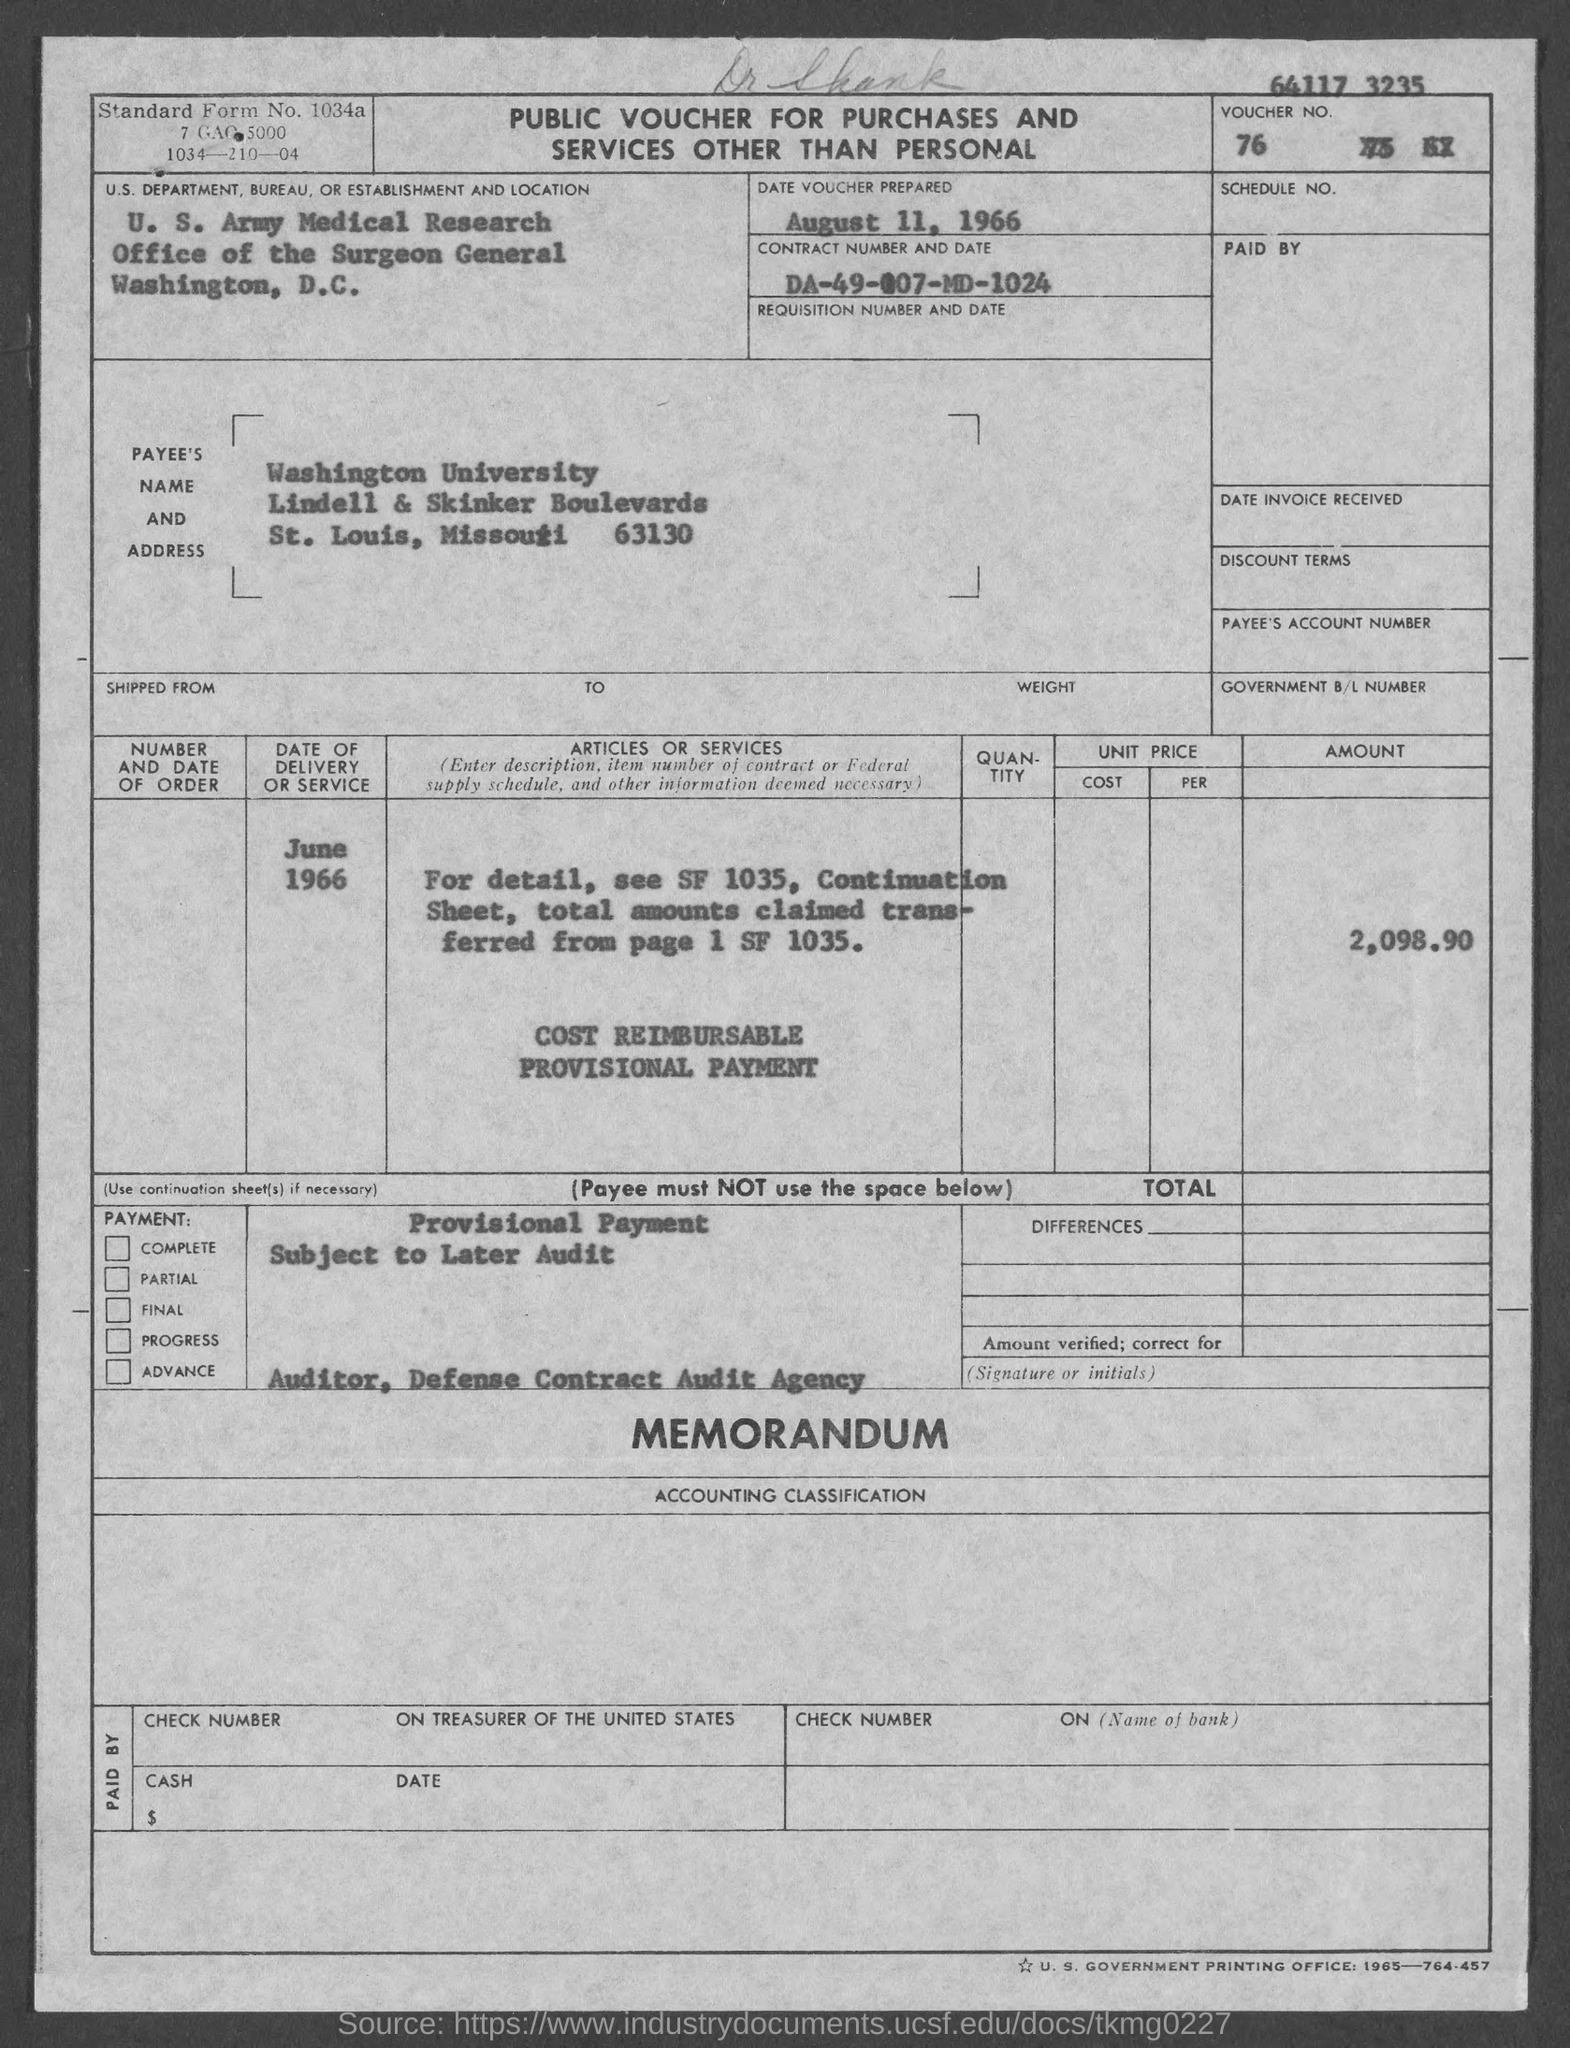When is the date voucher prepared?
Keep it short and to the point. August 11, 1966. What is the Contract Number and Date?
Your answer should be very brief. DA-49-007-MD-1024. What is the date of delivery or service?
Offer a very short reply. June 1966. What is the Amount?
Provide a short and direct response. 2,098.90. 